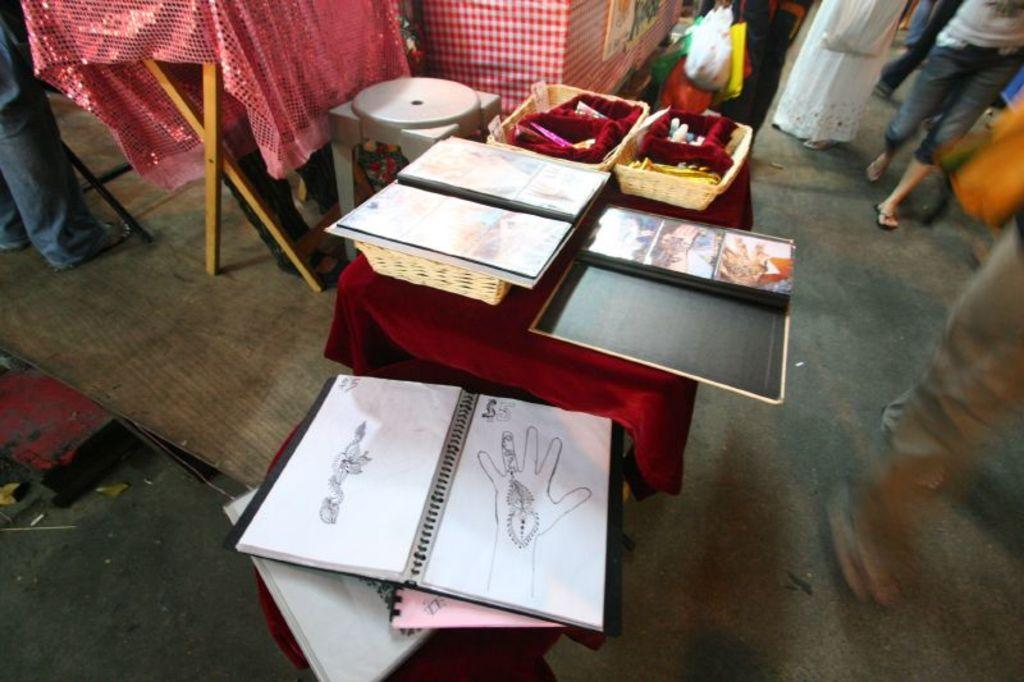What objects are on the table in the image? There are containers on the table in the image, which are books. What type of furniture is present in the image? There is a table in the image. How many people are visible in the image? There is one person standing and another person walking in the image. What items can be seen in addition to the books and table? There are bags in the image. What type of soup is being served in the cup in the image? There is no soup or cup present in the image. 